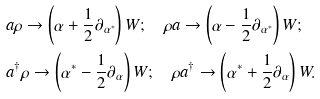<formula> <loc_0><loc_0><loc_500><loc_500>& a \rho \rightarrow \left ( \alpha + \frac { 1 } { 2 } \partial _ { \alpha ^ { * } } \right ) W ; \quad \rho a \rightarrow \left ( \alpha - \frac { 1 } { 2 } \partial _ { \alpha ^ { * } } \right ) W ; \\ & a ^ { \dagger } \rho \rightarrow \left ( \alpha ^ { * } - \frac { 1 } { 2 } \partial _ { \alpha } \right ) W ; \quad \rho a ^ { \dagger } \rightarrow \left ( \alpha ^ { * } + \frac { 1 } { 2 } \partial _ { \alpha } \right ) W .</formula> 